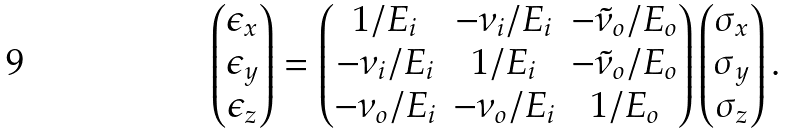<formula> <loc_0><loc_0><loc_500><loc_500>\begin{pmatrix} \epsilon _ { x } \\ \epsilon _ { y } \\ \epsilon _ { z } \end{pmatrix} = \begin{pmatrix} 1 / E _ { i } & - \nu _ { i } / E _ { i } & - \tilde { \nu } _ { o } / E _ { o } \\ - \nu _ { i } / E _ { i } & 1 / E _ { i } & - \tilde { \nu } _ { o } / E _ { o } \\ - \nu _ { o } / E _ { i } & - \nu _ { o } / E _ { i } & 1 / E _ { o } \end{pmatrix} \begin{pmatrix} \sigma _ { x } \\ \sigma _ { y } \\ \sigma _ { z } \end{pmatrix} .</formula> 